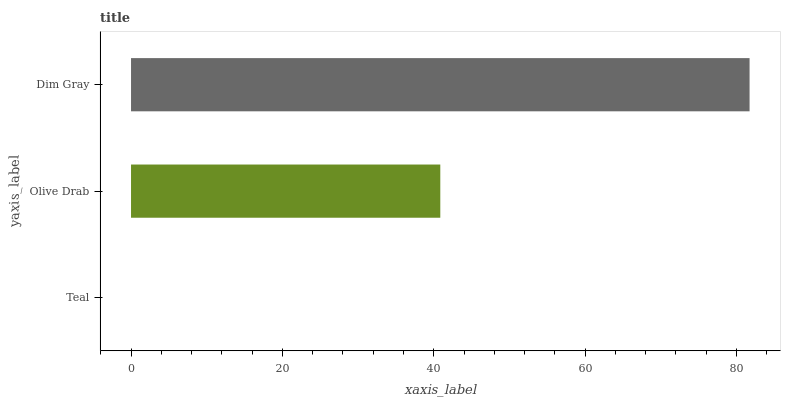Is Teal the minimum?
Answer yes or no. Yes. Is Dim Gray the maximum?
Answer yes or no. Yes. Is Olive Drab the minimum?
Answer yes or no. No. Is Olive Drab the maximum?
Answer yes or no. No. Is Olive Drab greater than Teal?
Answer yes or no. Yes. Is Teal less than Olive Drab?
Answer yes or no. Yes. Is Teal greater than Olive Drab?
Answer yes or no. No. Is Olive Drab less than Teal?
Answer yes or no. No. Is Olive Drab the high median?
Answer yes or no. Yes. Is Olive Drab the low median?
Answer yes or no. Yes. Is Teal the high median?
Answer yes or no. No. Is Dim Gray the low median?
Answer yes or no. No. 